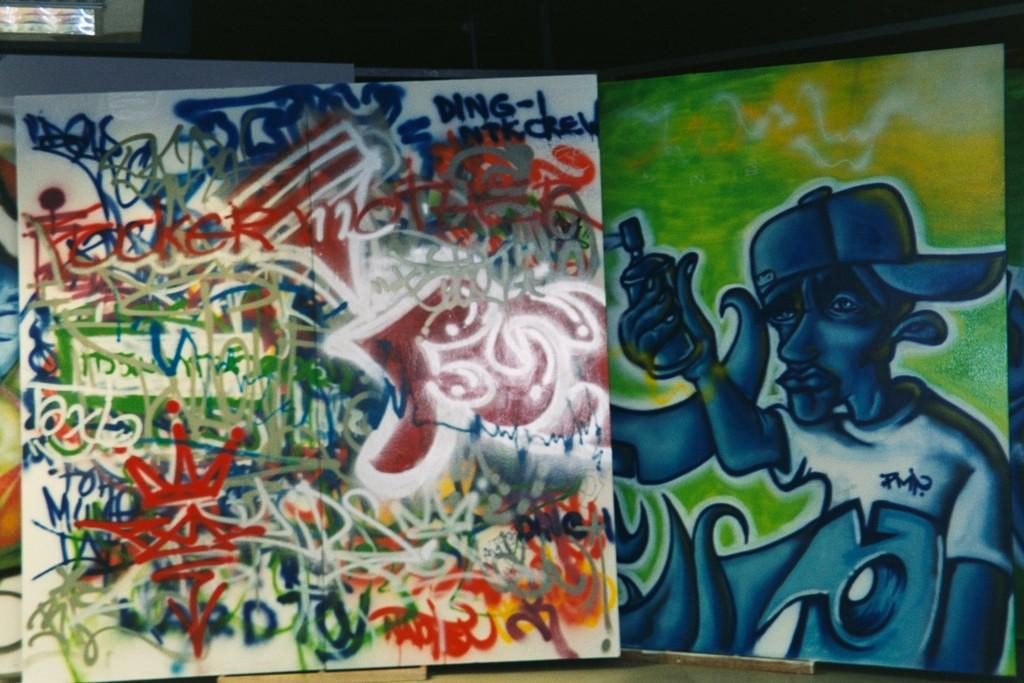What type of artwork can be seen on the boards in the image? There are boards with graffiti in the image. Can you describe the location of the window in the image? The window is located on the left top of the image. What type of jeans is the thing wearing in the image? There is no person or thing wearing jeans in the image; it only features boards with graffiti and a window. 